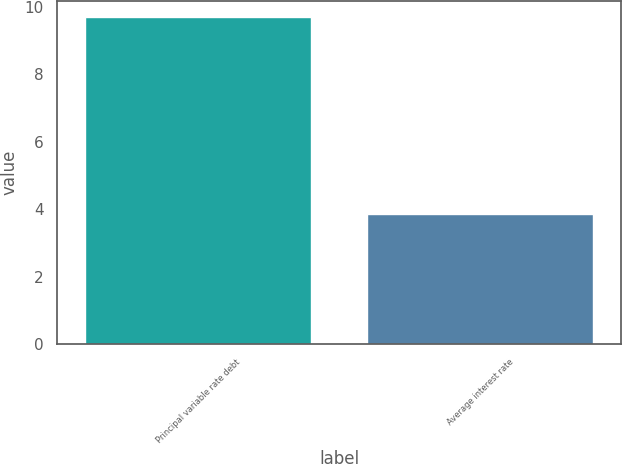<chart> <loc_0><loc_0><loc_500><loc_500><bar_chart><fcel>Principal variable rate debt<fcel>Average interest rate<nl><fcel>9.7<fcel>3.86<nl></chart> 